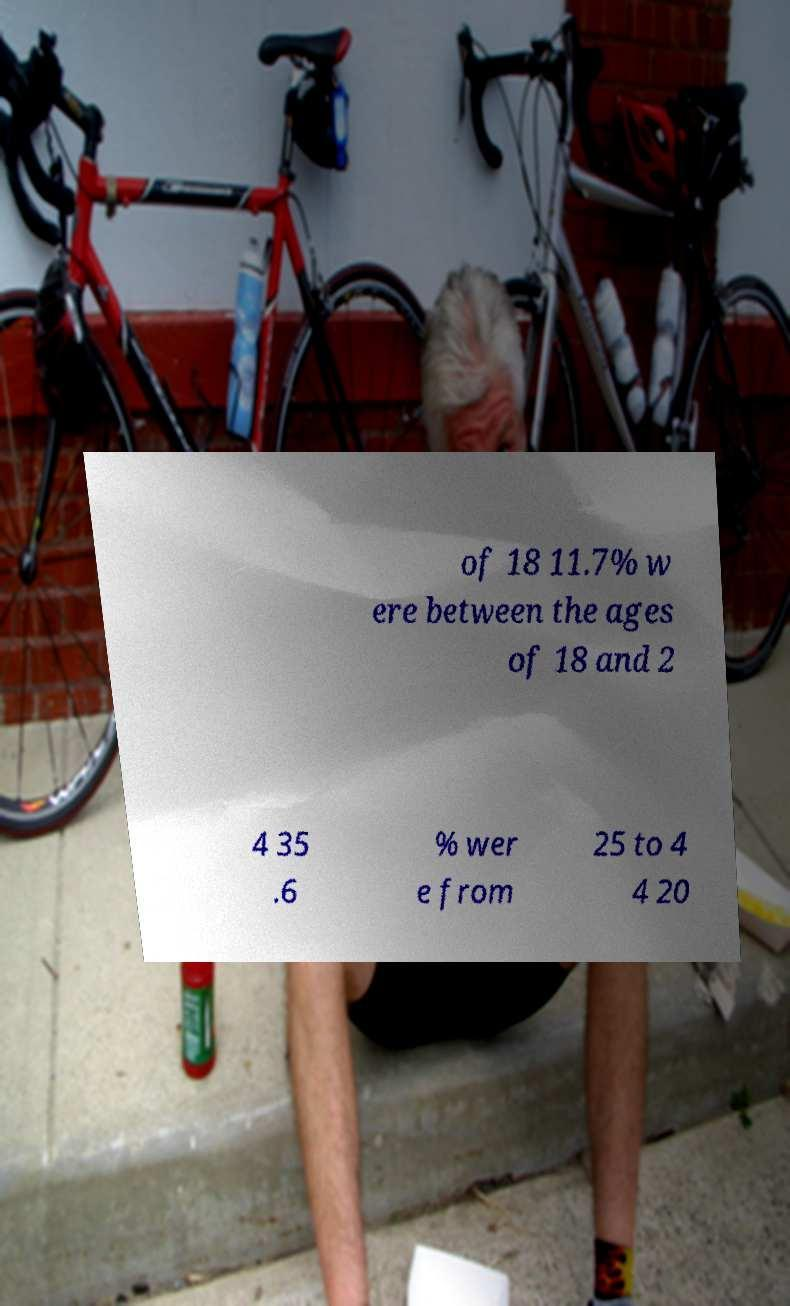There's text embedded in this image that I need extracted. Can you transcribe it verbatim? of 18 11.7% w ere between the ages of 18 and 2 4 35 .6 % wer e from 25 to 4 4 20 